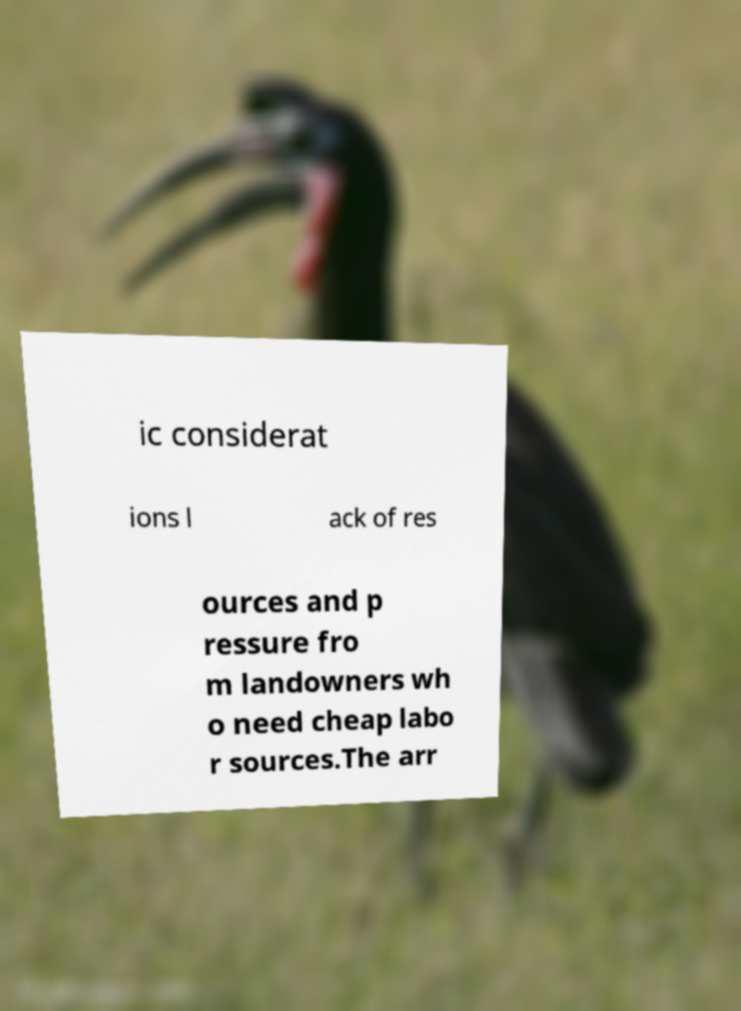Please read and relay the text visible in this image. What does it say? ic considerat ions l ack of res ources and p ressure fro m landowners wh o need cheap labo r sources.The arr 